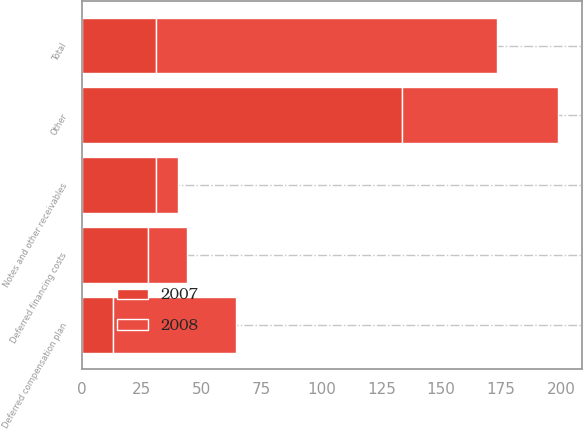Convert chart. <chart><loc_0><loc_0><loc_500><loc_500><stacked_bar_chart><ecel><fcel>Deferred financing costs<fcel>Deferred compensation plan<fcel>Notes and other receivables<fcel>Other<fcel>Total<nl><fcel>2007<fcel>27.4<fcel>13<fcel>30.7<fcel>133.8<fcel>30.7<nl><fcel>2008<fcel>16.3<fcel>51.5<fcel>9.5<fcel>65.2<fcel>142.5<nl></chart> 